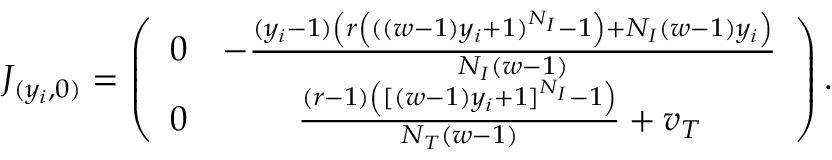<formula> <loc_0><loc_0><loc_500><loc_500>J _ { ( y _ { i } , 0 ) } = \left ( \begin{array} { c c } { 0 } & { - \frac { ( y _ { i } - 1 ) \left ( r \left ( ( ( w - 1 ) y _ { i } + 1 ) ^ { N _ { I } } - 1 \right ) + N _ { I } ( w - 1 ) y _ { i } \right ) } { N _ { I } ( w - 1 ) } } \\ { 0 } & { \frac { ( r - 1 ) \left ( [ ( w - 1 ) y _ { i } + 1 ] ^ { N _ { I } } - 1 \right ) } { N _ { T } ( w - 1 ) } + v _ { T } } \end{array} \right ) .</formula> 